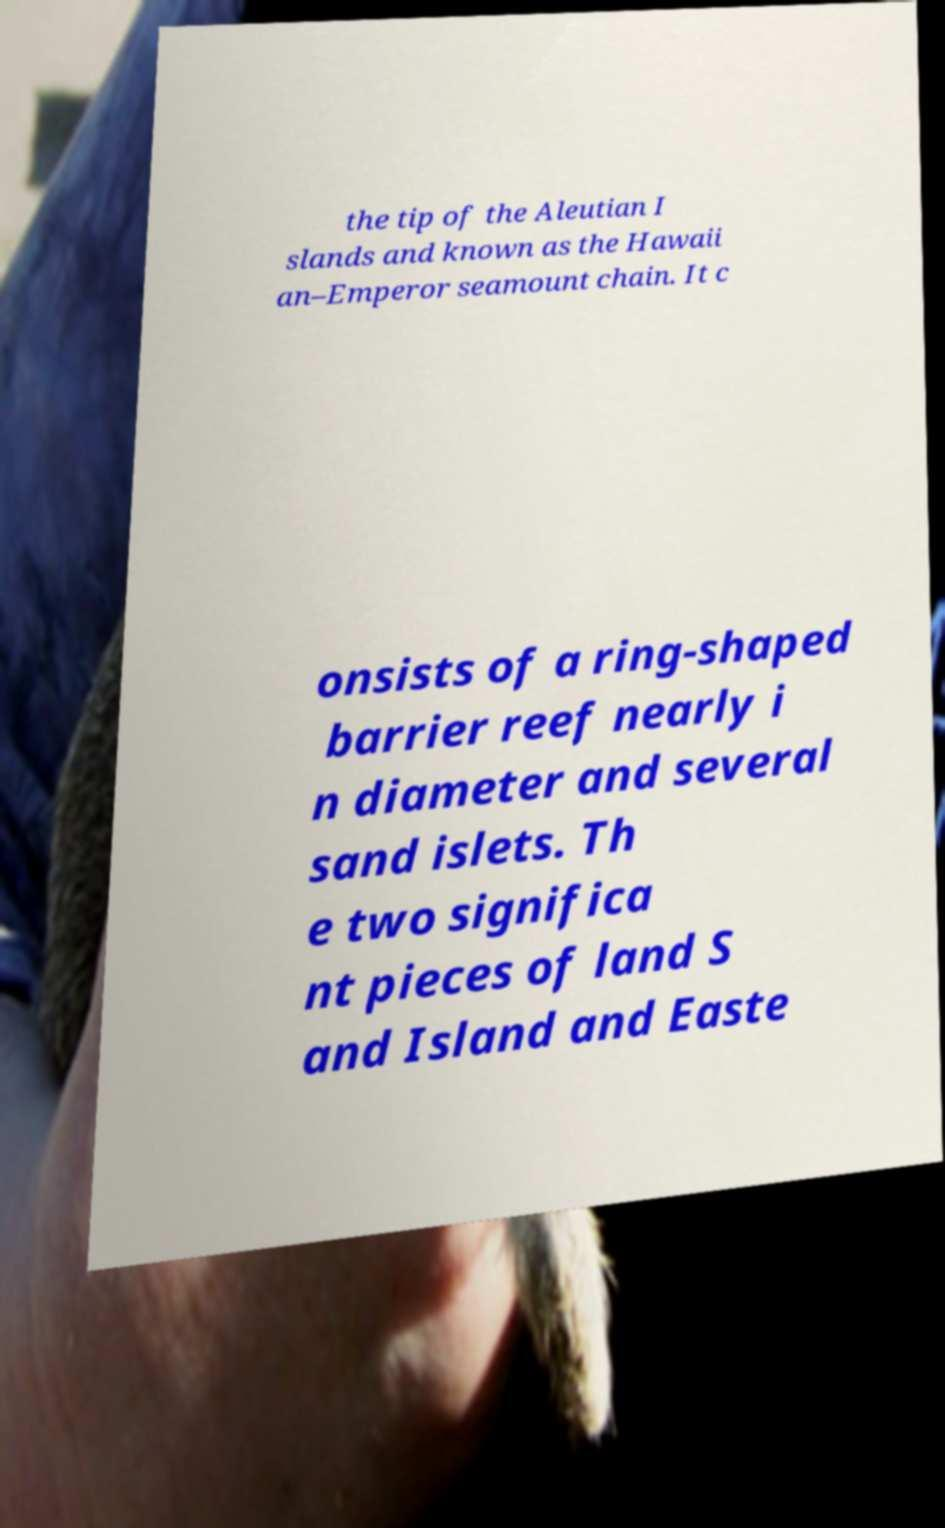Could you extract and type out the text from this image? the tip of the Aleutian I slands and known as the Hawaii an–Emperor seamount chain. It c onsists of a ring-shaped barrier reef nearly i n diameter and several sand islets. Th e two significa nt pieces of land S and Island and Easte 